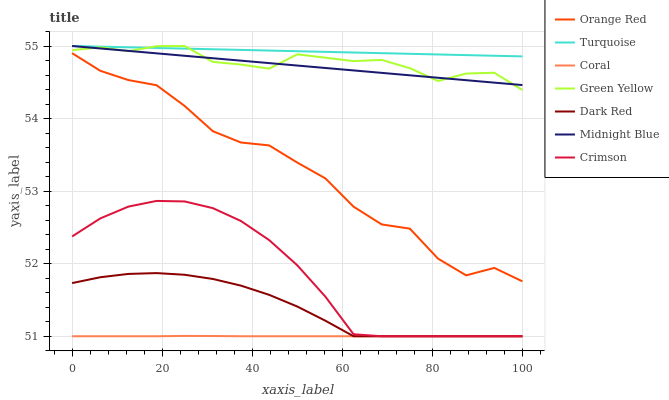Does Coral have the minimum area under the curve?
Answer yes or no. Yes. Does Turquoise have the maximum area under the curve?
Answer yes or no. Yes. Does Midnight Blue have the minimum area under the curve?
Answer yes or no. No. Does Midnight Blue have the maximum area under the curve?
Answer yes or no. No. Is Midnight Blue the smoothest?
Answer yes or no. Yes. Is Orange Red the roughest?
Answer yes or no. Yes. Is Dark Red the smoothest?
Answer yes or no. No. Is Dark Red the roughest?
Answer yes or no. No. Does Dark Red have the lowest value?
Answer yes or no. Yes. Does Midnight Blue have the lowest value?
Answer yes or no. No. Does Green Yellow have the highest value?
Answer yes or no. Yes. Does Dark Red have the highest value?
Answer yes or no. No. Is Crimson less than Midnight Blue?
Answer yes or no. Yes. Is Green Yellow greater than Coral?
Answer yes or no. Yes. Does Dark Red intersect Crimson?
Answer yes or no. Yes. Is Dark Red less than Crimson?
Answer yes or no. No. Is Dark Red greater than Crimson?
Answer yes or no. No. Does Crimson intersect Midnight Blue?
Answer yes or no. No. 